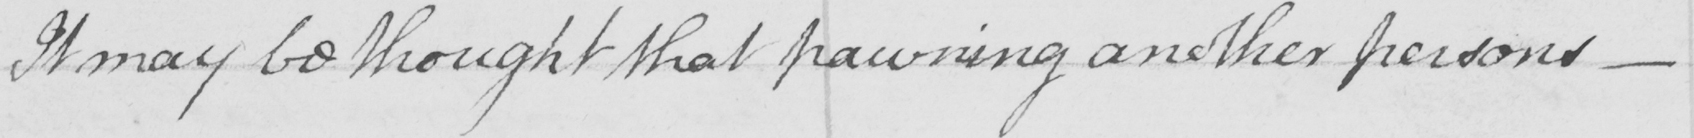Transcribe the text shown in this historical manuscript line. It may be thought that pawning another persons  _ 